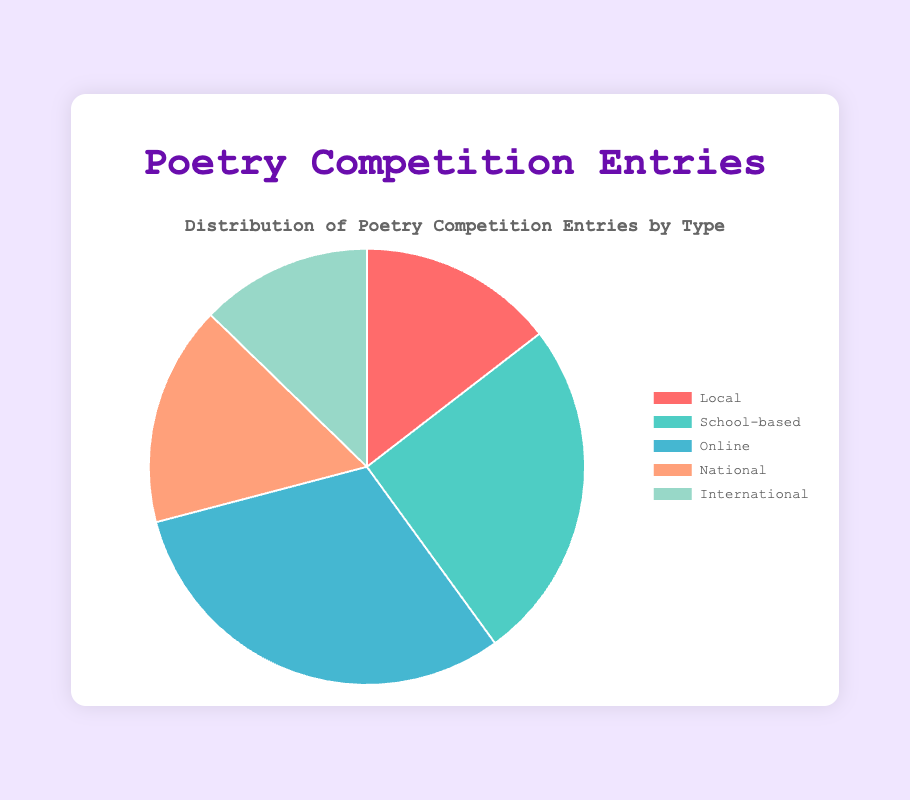What is the total number of entries for each type of poetry competition? To find the total number of entries for each type, sum the entries for all competitions of that type: Local (5 + 3 = 8), School-based (6 + 8 = 14), Online (10 + 7 = 17), National (4 + 5 = 9), International (3 + 4 = 7)
Answer: Local: 8, School-based: 14, Online: 17, National: 9, International: 7 Which type of poetry competition has the most entries? By comparing the total entries for each type: Local (8), School-based (14), Online (17), National (9), International (7), Online has the most entries with 17
Answer: Online How many more entries does the School-based category have compared to the Local category? Subtract the total entries of Local from School-based. School-based (14) - Local (8) = 6
Answer: 6 What percentage of the total entries are for the International competitions? Calculate the total number of entries for all types (8 + 14 + 17 + 9 + 7 = 55). Then, divide the entries for International by this total and multiply by 100: (7 / 55) * 100 ≈ 12.73%
Answer: 12.73% What is the second least entered type of competition? By comparing the total entries: Local (8), School-based (14), Online (17), National (9), International (7), the second least is Local with 8 entries
Answer: Local How many types of poetry competitions have entries in double digits? Count the types with entries of 10 or more: School-based (14) and Online (17)
Answer: 2 Among the National and International competitions, which has fewer entries? National has 9 entries and International has 7 entries. International has fewer.
Answer: International What is the combined total number of entries for Online and School-based competitions? Add the total entries for Online and School-based: Online (17) + School-based (14) = 31
Answer: 31 What fraction of the total entries do the National competitions represent? Calculate the total number of entries for all types (8 + 14 + 17 + 9 + 7 = 55). Then express National entries as a fraction of this total: National (9 / 55)
Answer: 9/55 